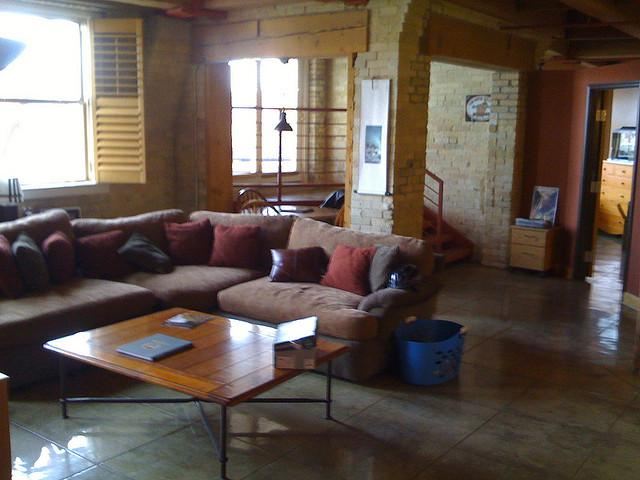What is on the table? book 